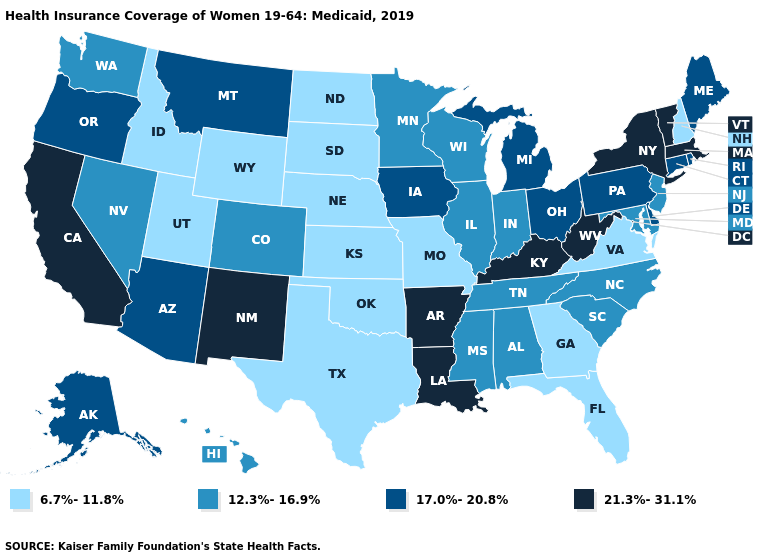Which states hav the highest value in the West?
Write a very short answer. California, New Mexico. Name the states that have a value in the range 17.0%-20.8%?
Quick response, please. Alaska, Arizona, Connecticut, Delaware, Iowa, Maine, Michigan, Montana, Ohio, Oregon, Pennsylvania, Rhode Island. Does Montana have the lowest value in the West?
Short answer required. No. What is the value of Oregon?
Write a very short answer. 17.0%-20.8%. Name the states that have a value in the range 6.7%-11.8%?
Keep it brief. Florida, Georgia, Idaho, Kansas, Missouri, Nebraska, New Hampshire, North Dakota, Oklahoma, South Dakota, Texas, Utah, Virginia, Wyoming. What is the lowest value in states that border Massachusetts?
Keep it brief. 6.7%-11.8%. Name the states that have a value in the range 6.7%-11.8%?
Concise answer only. Florida, Georgia, Idaho, Kansas, Missouri, Nebraska, New Hampshire, North Dakota, Oklahoma, South Dakota, Texas, Utah, Virginia, Wyoming. What is the value of North Dakota?
Give a very brief answer. 6.7%-11.8%. Does the map have missing data?
Concise answer only. No. What is the value of Colorado?
Write a very short answer. 12.3%-16.9%. What is the value of Pennsylvania?
Give a very brief answer. 17.0%-20.8%. Does North Carolina have the same value as Rhode Island?
Write a very short answer. No. Does New Hampshire have the lowest value in the Northeast?
Be succinct. Yes. What is the value of Montana?
Quick response, please. 17.0%-20.8%. Which states have the highest value in the USA?
Concise answer only. Arkansas, California, Kentucky, Louisiana, Massachusetts, New Mexico, New York, Vermont, West Virginia. 